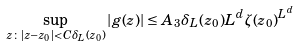Convert formula to latex. <formula><loc_0><loc_0><loc_500><loc_500>\sup _ { z \colon | z - z _ { 0 } | < C \delta _ { L } ( z _ { 0 } ) } | g ( z ) | \leq A _ { 3 } \delta _ { L } ( z _ { 0 } ) L ^ { d } \zeta ( z _ { 0 } ) ^ { L ^ { d } }</formula> 